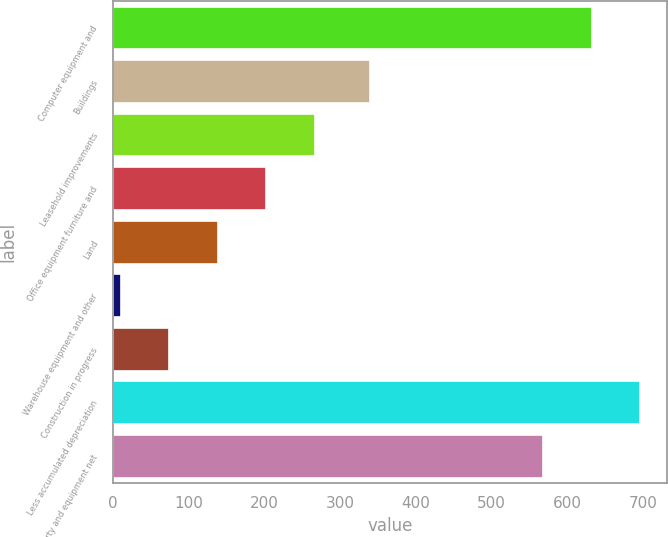Convert chart. <chart><loc_0><loc_0><loc_500><loc_500><bar_chart><fcel>Computer equipment and<fcel>Buildings<fcel>Leasehold improvements<fcel>Office equipment furniture and<fcel>Land<fcel>Warehouse equipment and other<fcel>Construction in progress<fcel>Less accumulated depreciation<fcel>Property and equipment net<nl><fcel>632.1<fcel>339<fcel>266.4<fcel>202.3<fcel>138.2<fcel>10<fcel>74.1<fcel>696.2<fcel>568<nl></chart> 